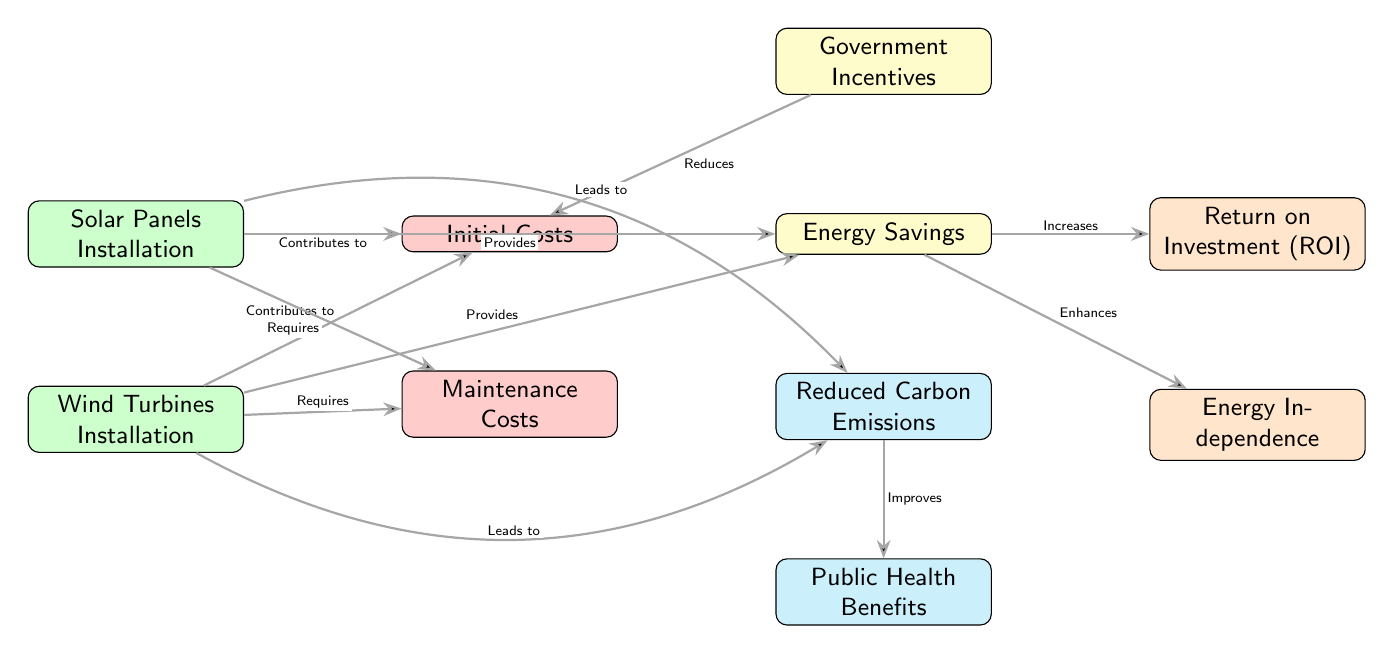What are the two types of renewable energy sources listed? The diagram shows two renewable energy sources: Solar Panels Installation and Wind Turbines Installation. These are the only sources indicated in the nodes at the top of the diagram.
Answer: Solar Panels Installation and Wind Turbines Installation What type of costs are related to the renewable energy sources? The diagram indicates two types of costs: Initial Costs and Maintenance Costs, which are highlighted in red and located to the right of the renewable energy sources.
Answer: Initial Costs and Maintenance Costs What does the diagram indicate as an outcome of energy savings? According to the diagram, Energy Savings increases Return on Investment, showing the financial benefits of implementing renewable energy solutions. This relationship is highlighted in yellow and orange in the diagram.
Answer: Return on Investment (ROI) Which element contributes to reducing initial costs? The diagram states that Government Incentives reduce Initial Costs, as shown by an edge connecting Government Incentives to Initial Costs. This illustrates the financial support available for renewable energy investments.
Answer: Government Incentives How do the renewable energy sources lead to environmental benefits? The diagram shows that both Solar Panels and Wind Turbines lead to Reduced Carbon Emissions. This information is represented with a connection that indicates they contribute directly to a decrease in emissions, which further improves Public Health Benefits.
Answer: Reduced Carbon Emissions What connection exists between Energy Savings and Independence? The diagram connects Energy Savings to Energy Independence, indicating that as energy savings grow, so does the independence from traditional energy sources. This reflects how cost savings can lead to more self-sufficient energy practices.
Answer: Energy Independence How many nodes are represented in the diagram? The diagram features a total of ten nodes, including both energy sources, costs, savings, incentives, emissions, health benefits, ROI, and independence. Each node contributes differently to the overall message of renewable energy benefits.
Answer: Ten nodes What does the edge labeled "Leads to" indicate about the renewable energy sources? The diagram's edges indicating "Leads to" show that both Solar Panels and Wind Turbines contribute positively to Reduced Carbon Emissions, emphasizing their role in improving environmental outcomes as a result of implementation.
Answer: Reduced Carbon Emissions What is illustrated by the relationship between Reduced Carbon Emissions and Public Health Benefits? The diagram illustrates that Reduced Carbon Emissions improves Public Health Benefits, suggesting that less pollution contributes to better health outcomes in the community, highlighting the dual focus on economic impact and public health.
Answer: Public Health Benefits 